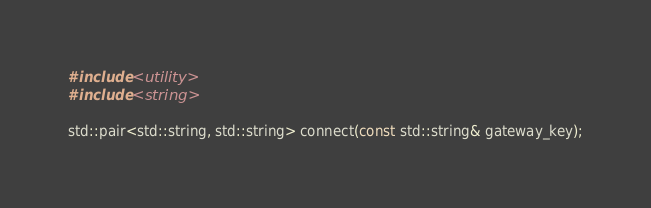Convert code to text. <code><loc_0><loc_0><loc_500><loc_500><_C_>#include <utility>
#include <string>

std::pair<std::string, std::string> connect(const std::string& gateway_key);</code> 